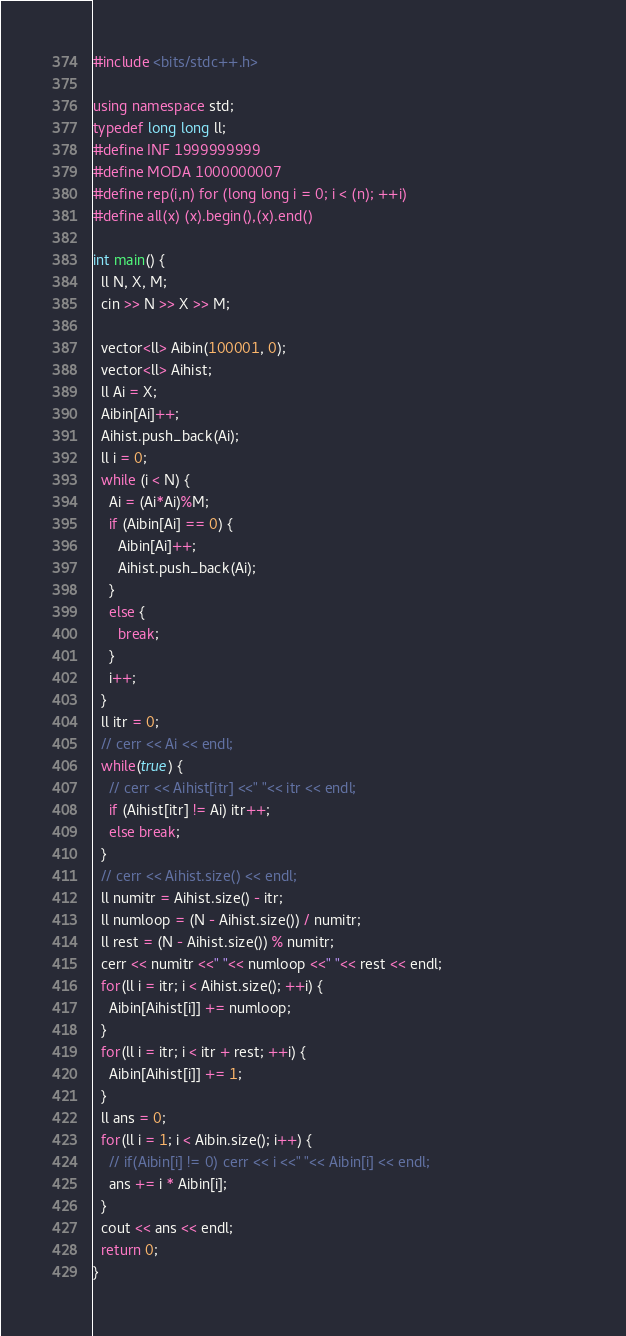Convert code to text. <code><loc_0><loc_0><loc_500><loc_500><_C++_>#include <bits/stdc++.h>

using namespace std;
typedef long long ll;
#define INF 1999999999
#define MODA 1000000007 
#define rep(i,n) for (long long i = 0; i < (n); ++i)
#define all(x) (x).begin(),(x).end()

int main() {                                                                                                    
  ll N, X, M;
  cin >> N >> X >> M;

  vector<ll> Aibin(100001, 0);
  vector<ll> Aihist;
  ll Ai = X;
  Aibin[Ai]++;
  Aihist.push_back(Ai);
  ll i = 0;
  while (i < N) {
    Ai = (Ai*Ai)%M;
    if (Aibin[Ai] == 0) {
      Aibin[Ai]++;
      Aihist.push_back(Ai);
    }
    else {
      break;
    }
    i++;
  }
  ll itr = 0;
  // cerr << Ai << endl;
  while(true) {
    // cerr << Aihist[itr] <<" "<< itr << endl;
    if (Aihist[itr] != Ai) itr++;
    else break;
  }
  // cerr << Aihist.size() << endl;
  ll numitr = Aihist.size() - itr;
  ll numloop = (N - Aihist.size()) / numitr;
  ll rest = (N - Aihist.size()) % numitr;
  cerr << numitr <<" "<< numloop <<" "<< rest << endl;
  for(ll i = itr; i < Aihist.size(); ++i) {
    Aibin[Aihist[i]] += numloop;
  }
  for(ll i = itr; i < itr + rest; ++i) {
    Aibin[Aihist[i]] += 1;
  }
  ll ans = 0;
  for(ll i = 1; i < Aibin.size(); i++) {
    // if(Aibin[i] != 0) cerr << i <<" "<< Aibin[i] << endl;
    ans += i * Aibin[i];
  }
  cout << ans << endl;
  return 0;
}</code> 